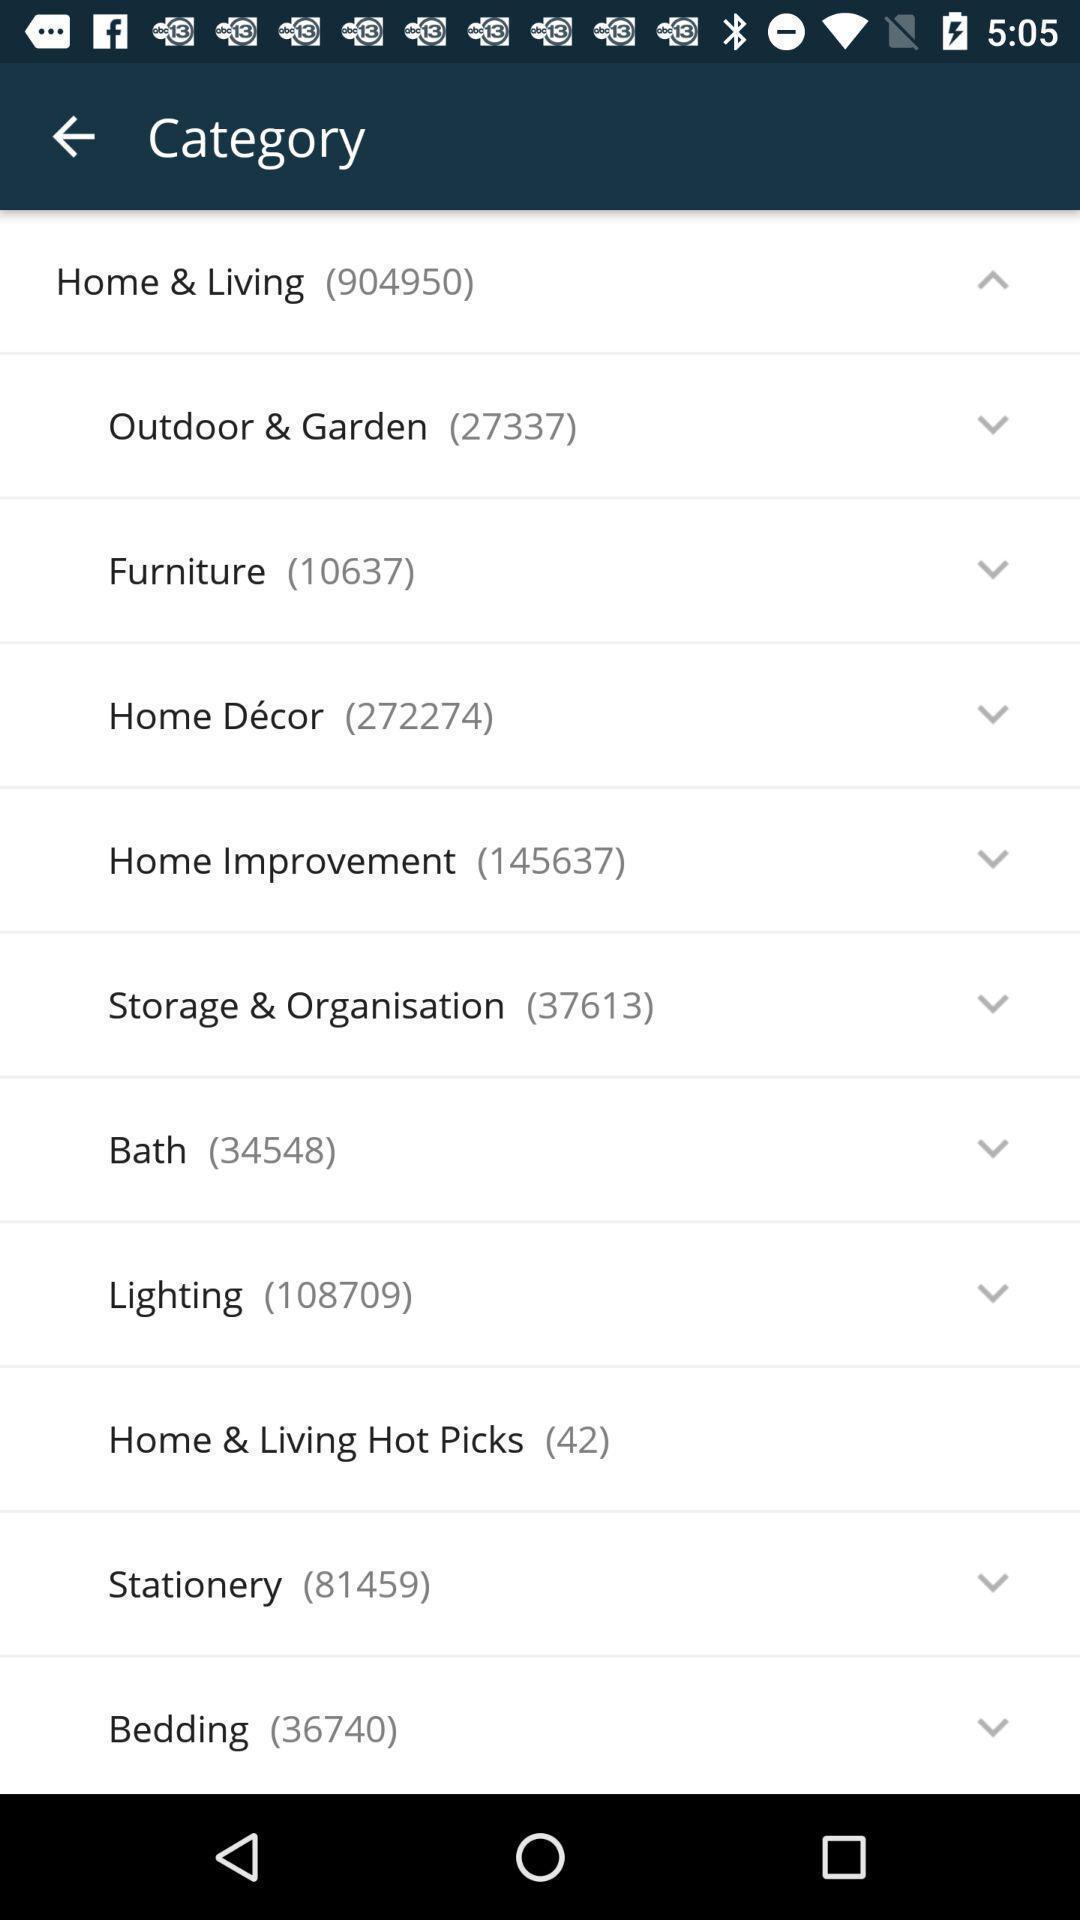Summarize the information in this screenshot. Page showing all the categories. 